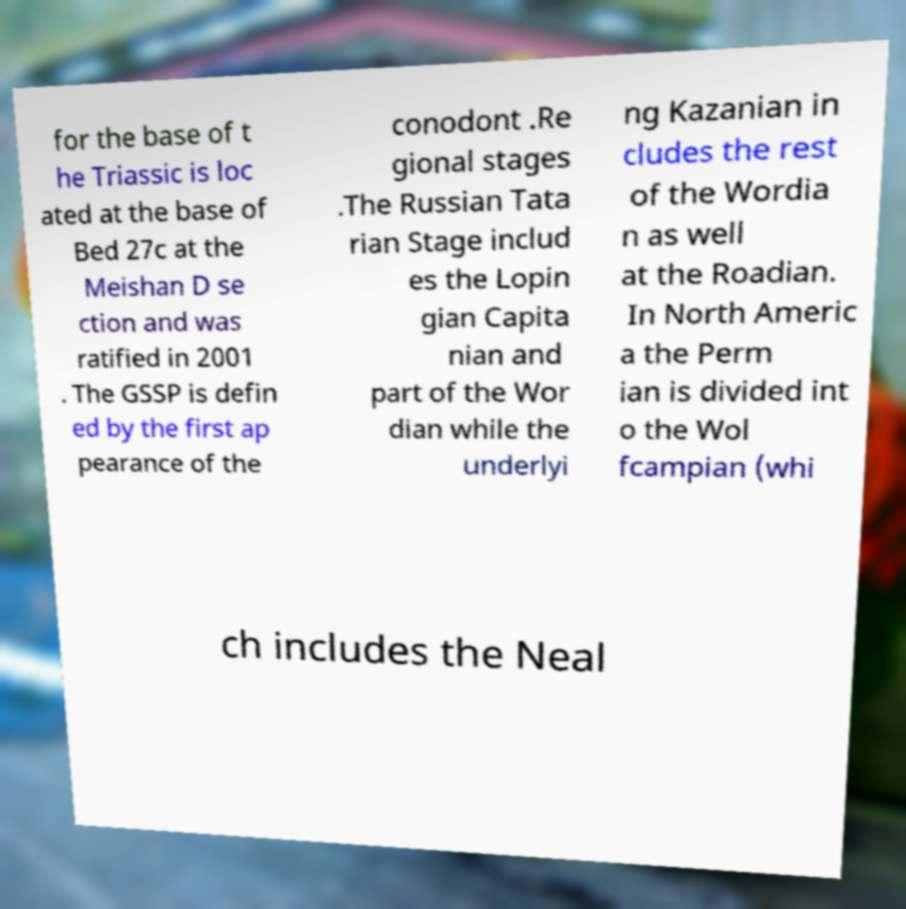Could you assist in decoding the text presented in this image and type it out clearly? for the base of t he Triassic is loc ated at the base of Bed 27c at the Meishan D se ction and was ratified in 2001 . The GSSP is defin ed by the first ap pearance of the conodont .Re gional stages .The Russian Tata rian Stage includ es the Lopin gian Capita nian and part of the Wor dian while the underlyi ng Kazanian in cludes the rest of the Wordia n as well at the Roadian. In North Americ a the Perm ian is divided int o the Wol fcampian (whi ch includes the Neal 